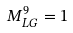<formula> <loc_0><loc_0><loc_500><loc_500>M _ { L G } ^ { 9 } = 1</formula> 